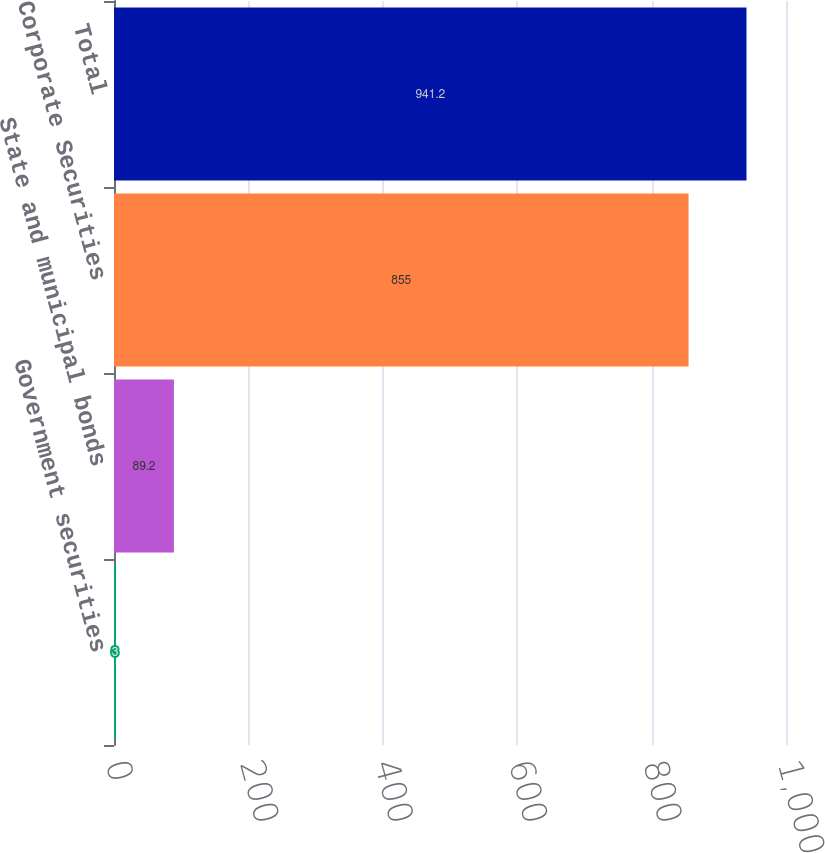<chart> <loc_0><loc_0><loc_500><loc_500><bar_chart><fcel>Government securities<fcel>State and municipal bonds<fcel>Corporate Securities<fcel>Total<nl><fcel>3<fcel>89.2<fcel>855<fcel>941.2<nl></chart> 